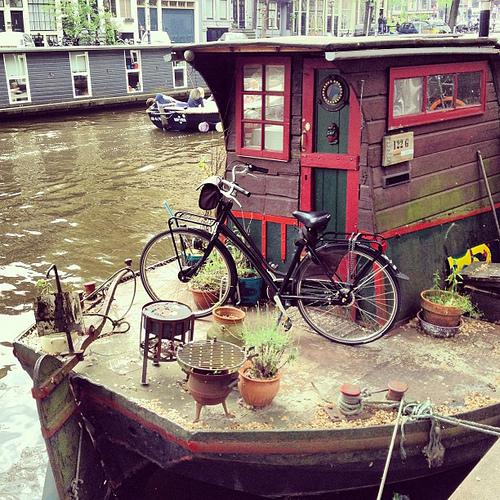Question: how many bikes are there?
Choices:
A. 2.
B. 1.
C. 3.
D. 4.
Answer with the letter. Answer: B Question: what is the color of the bike?
Choices:
A. Blue.
B. Green.
C. Black.
D. White.
Answer with the letter. Answer: C Question: what is beside the bike?
Choices:
A. Bushes.
B. Flowers.
C. Grass.
D. Sand.
Answer with the letter. Answer: B Question: when was the pic taken?
Choices:
A. Night.
B. Sunrise.
C. Sunset.
D. During the day.
Answer with the letter. Answer: D 